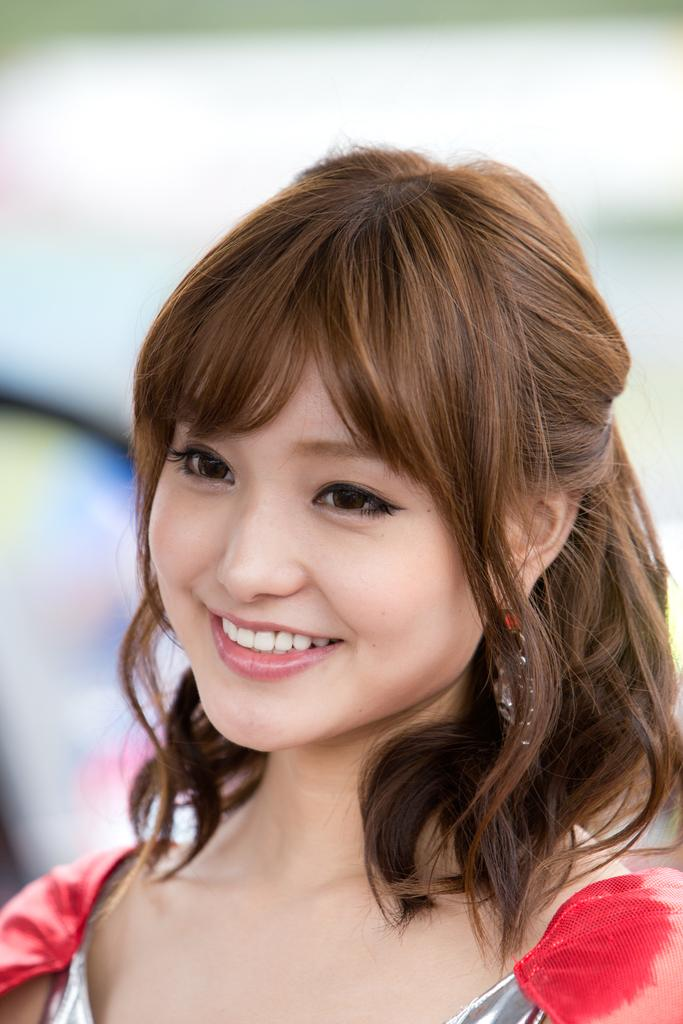Who is the main subject in the image? There is a woman in the image. Where is the woman located in the image? The woman is in the front of the image. What is the woman's facial expression in the image? The woman is smiling in the image. What type of apples can be seen hanging from the woman's ears in the image? There are no apples present in the image, nor are there any apples hanging from the woman's ears. 